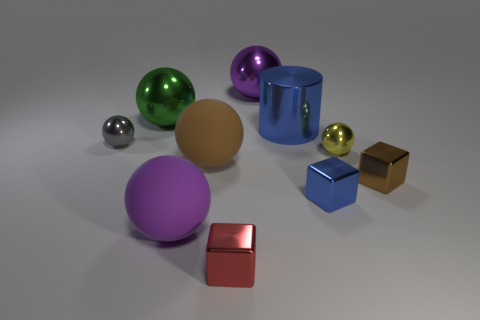Subtract all gray balls. How many balls are left? 5 Subtract all tiny yellow balls. How many balls are left? 5 Subtract all red spheres. Subtract all green cylinders. How many spheres are left? 6 Subtract all cylinders. How many objects are left? 9 Subtract all blue blocks. Subtract all small metallic objects. How many objects are left? 4 Add 8 yellow things. How many yellow things are left? 9 Add 2 small yellow matte balls. How many small yellow matte balls exist? 2 Subtract 1 gray balls. How many objects are left? 9 